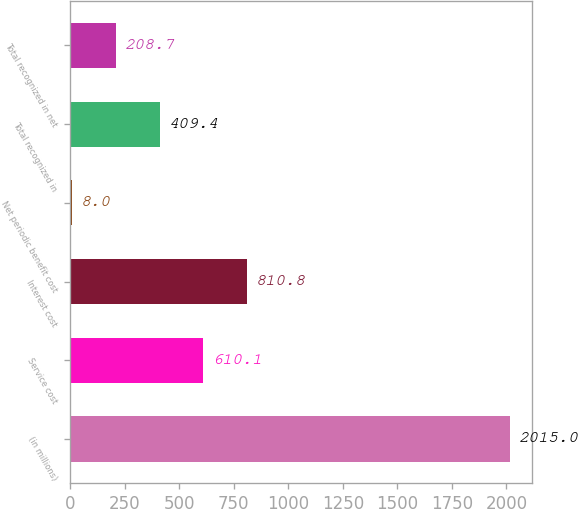Convert chart to OTSL. <chart><loc_0><loc_0><loc_500><loc_500><bar_chart><fcel>(in millions)<fcel>Service cost<fcel>Interest cost<fcel>Net periodic benefit cost<fcel>Total recognized in<fcel>Total recognized in net<nl><fcel>2015<fcel>610.1<fcel>810.8<fcel>8<fcel>409.4<fcel>208.7<nl></chart> 